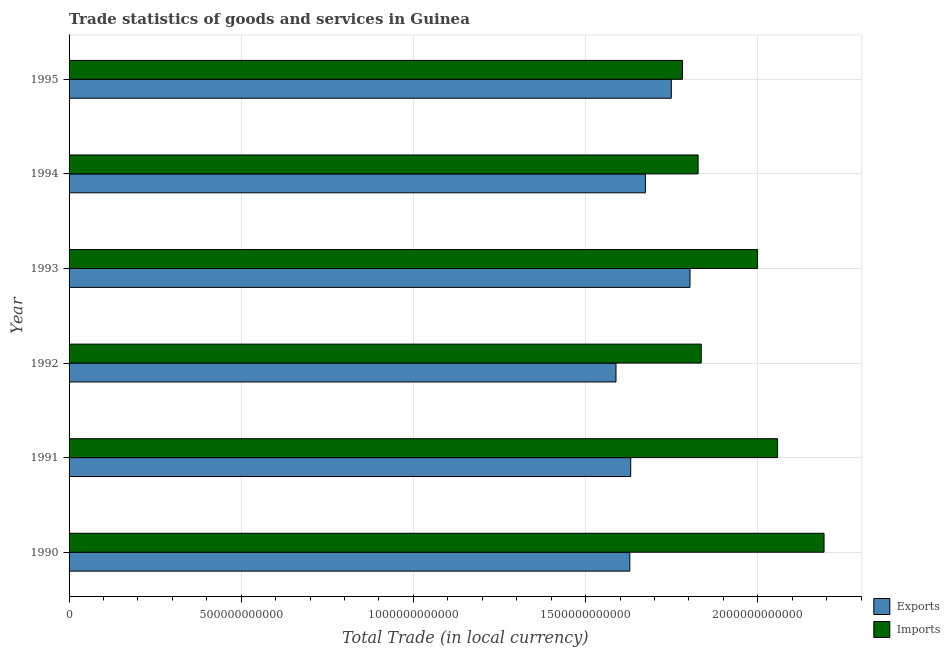How many different coloured bars are there?
Your response must be concise. 2. How many groups of bars are there?
Your answer should be very brief. 6. Are the number of bars on each tick of the Y-axis equal?
Provide a succinct answer. Yes. In how many cases, is the number of bars for a given year not equal to the number of legend labels?
Offer a very short reply. 0. What is the imports of goods and services in 1995?
Make the answer very short. 1.78e+12. Across all years, what is the maximum imports of goods and services?
Ensure brevity in your answer.  2.19e+12. Across all years, what is the minimum export of goods and services?
Keep it short and to the point. 1.59e+12. In which year was the imports of goods and services maximum?
Your answer should be very brief. 1990. In which year was the export of goods and services minimum?
Ensure brevity in your answer.  1992. What is the total export of goods and services in the graph?
Offer a very short reply. 1.01e+13. What is the difference between the imports of goods and services in 1990 and that in 1995?
Your answer should be compact. 4.11e+11. What is the difference between the imports of goods and services in 1991 and the export of goods and services in 1994?
Your answer should be compact. 3.84e+11. What is the average imports of goods and services per year?
Your answer should be compact. 1.95e+12. In the year 1992, what is the difference between the imports of goods and services and export of goods and services?
Your answer should be compact. 2.48e+11. What is the difference between the highest and the second highest imports of goods and services?
Your answer should be compact. 1.35e+11. What is the difference between the highest and the lowest imports of goods and services?
Your response must be concise. 4.11e+11. Is the sum of the export of goods and services in 1990 and 1995 greater than the maximum imports of goods and services across all years?
Your response must be concise. Yes. What does the 2nd bar from the top in 1993 represents?
Offer a very short reply. Exports. What does the 2nd bar from the bottom in 1991 represents?
Your response must be concise. Imports. What is the difference between two consecutive major ticks on the X-axis?
Provide a short and direct response. 5.00e+11. Are the values on the major ticks of X-axis written in scientific E-notation?
Your response must be concise. No. How are the legend labels stacked?
Offer a very short reply. Vertical. What is the title of the graph?
Your answer should be compact. Trade statistics of goods and services in Guinea. Does "Nitrous oxide emissions" appear as one of the legend labels in the graph?
Your response must be concise. No. What is the label or title of the X-axis?
Your response must be concise. Total Trade (in local currency). What is the Total Trade (in local currency) in Exports in 1990?
Ensure brevity in your answer.  1.63e+12. What is the Total Trade (in local currency) of Imports in 1990?
Your response must be concise. 2.19e+12. What is the Total Trade (in local currency) in Exports in 1991?
Ensure brevity in your answer.  1.63e+12. What is the Total Trade (in local currency) of Imports in 1991?
Make the answer very short. 2.06e+12. What is the Total Trade (in local currency) of Exports in 1992?
Offer a terse response. 1.59e+12. What is the Total Trade (in local currency) of Imports in 1992?
Make the answer very short. 1.84e+12. What is the Total Trade (in local currency) in Exports in 1993?
Your answer should be compact. 1.80e+12. What is the Total Trade (in local currency) of Imports in 1993?
Make the answer very short. 2.00e+12. What is the Total Trade (in local currency) in Exports in 1994?
Keep it short and to the point. 1.67e+12. What is the Total Trade (in local currency) in Imports in 1994?
Give a very brief answer. 1.83e+12. What is the Total Trade (in local currency) of Exports in 1995?
Offer a terse response. 1.75e+12. What is the Total Trade (in local currency) in Imports in 1995?
Offer a terse response. 1.78e+12. Across all years, what is the maximum Total Trade (in local currency) in Exports?
Provide a short and direct response. 1.80e+12. Across all years, what is the maximum Total Trade (in local currency) in Imports?
Offer a terse response. 2.19e+12. Across all years, what is the minimum Total Trade (in local currency) in Exports?
Make the answer very short. 1.59e+12. Across all years, what is the minimum Total Trade (in local currency) in Imports?
Your answer should be compact. 1.78e+12. What is the total Total Trade (in local currency) in Exports in the graph?
Your answer should be compact. 1.01e+13. What is the total Total Trade (in local currency) in Imports in the graph?
Offer a terse response. 1.17e+13. What is the difference between the Total Trade (in local currency) of Exports in 1990 and that in 1991?
Provide a short and direct response. -2.53e+09. What is the difference between the Total Trade (in local currency) in Imports in 1990 and that in 1991?
Your answer should be compact. 1.35e+11. What is the difference between the Total Trade (in local currency) in Exports in 1990 and that in 1992?
Give a very brief answer. 4.02e+1. What is the difference between the Total Trade (in local currency) of Imports in 1990 and that in 1992?
Ensure brevity in your answer.  3.57e+11. What is the difference between the Total Trade (in local currency) of Exports in 1990 and that in 1993?
Provide a succinct answer. -1.75e+11. What is the difference between the Total Trade (in local currency) in Imports in 1990 and that in 1993?
Provide a succinct answer. 1.93e+11. What is the difference between the Total Trade (in local currency) of Exports in 1990 and that in 1994?
Provide a short and direct response. -4.53e+1. What is the difference between the Total Trade (in local currency) in Imports in 1990 and that in 1994?
Provide a short and direct response. 3.66e+11. What is the difference between the Total Trade (in local currency) in Exports in 1990 and that in 1995?
Your response must be concise. -1.20e+11. What is the difference between the Total Trade (in local currency) of Imports in 1990 and that in 1995?
Offer a terse response. 4.11e+11. What is the difference between the Total Trade (in local currency) in Exports in 1991 and that in 1992?
Make the answer very short. 4.27e+1. What is the difference between the Total Trade (in local currency) of Imports in 1991 and that in 1992?
Your answer should be very brief. 2.22e+11. What is the difference between the Total Trade (in local currency) of Exports in 1991 and that in 1993?
Your answer should be compact. -1.72e+11. What is the difference between the Total Trade (in local currency) in Imports in 1991 and that in 1993?
Keep it short and to the point. 5.82e+1. What is the difference between the Total Trade (in local currency) in Exports in 1991 and that in 1994?
Your response must be concise. -4.27e+1. What is the difference between the Total Trade (in local currency) of Imports in 1991 and that in 1994?
Provide a short and direct response. 2.31e+11. What is the difference between the Total Trade (in local currency) of Exports in 1991 and that in 1995?
Make the answer very short. -1.18e+11. What is the difference between the Total Trade (in local currency) in Imports in 1991 and that in 1995?
Ensure brevity in your answer.  2.76e+11. What is the difference between the Total Trade (in local currency) of Exports in 1992 and that in 1993?
Provide a short and direct response. -2.15e+11. What is the difference between the Total Trade (in local currency) of Imports in 1992 and that in 1993?
Offer a very short reply. -1.64e+11. What is the difference between the Total Trade (in local currency) in Exports in 1992 and that in 1994?
Your response must be concise. -8.54e+1. What is the difference between the Total Trade (in local currency) in Imports in 1992 and that in 1994?
Provide a succinct answer. 9.11e+09. What is the difference between the Total Trade (in local currency) in Exports in 1992 and that in 1995?
Your answer should be compact. -1.61e+11. What is the difference between the Total Trade (in local currency) in Imports in 1992 and that in 1995?
Your answer should be very brief. 5.44e+1. What is the difference between the Total Trade (in local currency) in Exports in 1993 and that in 1994?
Keep it short and to the point. 1.29e+11. What is the difference between the Total Trade (in local currency) in Imports in 1993 and that in 1994?
Offer a terse response. 1.73e+11. What is the difference between the Total Trade (in local currency) of Exports in 1993 and that in 1995?
Give a very brief answer. 5.43e+1. What is the difference between the Total Trade (in local currency) in Imports in 1993 and that in 1995?
Make the answer very short. 2.18e+11. What is the difference between the Total Trade (in local currency) of Exports in 1994 and that in 1995?
Provide a short and direct response. -7.52e+1. What is the difference between the Total Trade (in local currency) of Imports in 1994 and that in 1995?
Keep it short and to the point. 4.53e+1. What is the difference between the Total Trade (in local currency) of Exports in 1990 and the Total Trade (in local currency) of Imports in 1991?
Keep it short and to the point. -4.29e+11. What is the difference between the Total Trade (in local currency) in Exports in 1990 and the Total Trade (in local currency) in Imports in 1992?
Your answer should be compact. -2.07e+11. What is the difference between the Total Trade (in local currency) in Exports in 1990 and the Total Trade (in local currency) in Imports in 1993?
Make the answer very short. -3.71e+11. What is the difference between the Total Trade (in local currency) in Exports in 1990 and the Total Trade (in local currency) in Imports in 1994?
Ensure brevity in your answer.  -1.98e+11. What is the difference between the Total Trade (in local currency) in Exports in 1990 and the Total Trade (in local currency) in Imports in 1995?
Make the answer very short. -1.53e+11. What is the difference between the Total Trade (in local currency) in Exports in 1991 and the Total Trade (in local currency) in Imports in 1992?
Offer a very short reply. -2.05e+11. What is the difference between the Total Trade (in local currency) of Exports in 1991 and the Total Trade (in local currency) of Imports in 1993?
Your answer should be compact. -3.68e+11. What is the difference between the Total Trade (in local currency) of Exports in 1991 and the Total Trade (in local currency) of Imports in 1994?
Give a very brief answer. -1.96e+11. What is the difference between the Total Trade (in local currency) of Exports in 1991 and the Total Trade (in local currency) of Imports in 1995?
Keep it short and to the point. -1.50e+11. What is the difference between the Total Trade (in local currency) in Exports in 1992 and the Total Trade (in local currency) in Imports in 1993?
Offer a terse response. -4.11e+11. What is the difference between the Total Trade (in local currency) of Exports in 1992 and the Total Trade (in local currency) of Imports in 1994?
Your answer should be compact. -2.38e+11. What is the difference between the Total Trade (in local currency) in Exports in 1992 and the Total Trade (in local currency) in Imports in 1995?
Your answer should be very brief. -1.93e+11. What is the difference between the Total Trade (in local currency) in Exports in 1993 and the Total Trade (in local currency) in Imports in 1994?
Your answer should be compact. -2.35e+1. What is the difference between the Total Trade (in local currency) in Exports in 1993 and the Total Trade (in local currency) in Imports in 1995?
Provide a short and direct response. 2.18e+1. What is the difference between the Total Trade (in local currency) of Exports in 1994 and the Total Trade (in local currency) of Imports in 1995?
Offer a very short reply. -1.08e+11. What is the average Total Trade (in local currency) in Exports per year?
Give a very brief answer. 1.68e+12. What is the average Total Trade (in local currency) of Imports per year?
Provide a succinct answer. 1.95e+12. In the year 1990, what is the difference between the Total Trade (in local currency) in Exports and Total Trade (in local currency) in Imports?
Give a very brief answer. -5.64e+11. In the year 1991, what is the difference between the Total Trade (in local currency) in Exports and Total Trade (in local currency) in Imports?
Provide a short and direct response. -4.27e+11. In the year 1992, what is the difference between the Total Trade (in local currency) of Exports and Total Trade (in local currency) of Imports?
Keep it short and to the point. -2.48e+11. In the year 1993, what is the difference between the Total Trade (in local currency) of Exports and Total Trade (in local currency) of Imports?
Provide a succinct answer. -1.96e+11. In the year 1994, what is the difference between the Total Trade (in local currency) in Exports and Total Trade (in local currency) in Imports?
Give a very brief answer. -1.53e+11. In the year 1995, what is the difference between the Total Trade (in local currency) in Exports and Total Trade (in local currency) in Imports?
Ensure brevity in your answer.  -3.25e+1. What is the ratio of the Total Trade (in local currency) of Exports in 1990 to that in 1991?
Give a very brief answer. 1. What is the ratio of the Total Trade (in local currency) of Imports in 1990 to that in 1991?
Give a very brief answer. 1.07. What is the ratio of the Total Trade (in local currency) of Exports in 1990 to that in 1992?
Your response must be concise. 1.03. What is the ratio of the Total Trade (in local currency) of Imports in 1990 to that in 1992?
Ensure brevity in your answer.  1.19. What is the ratio of the Total Trade (in local currency) in Exports in 1990 to that in 1993?
Provide a short and direct response. 0.9. What is the ratio of the Total Trade (in local currency) in Imports in 1990 to that in 1993?
Offer a terse response. 1.1. What is the ratio of the Total Trade (in local currency) in Exports in 1990 to that in 1994?
Your answer should be compact. 0.97. What is the ratio of the Total Trade (in local currency) of Imports in 1990 to that in 1994?
Ensure brevity in your answer.  1.2. What is the ratio of the Total Trade (in local currency) in Exports in 1990 to that in 1995?
Ensure brevity in your answer.  0.93. What is the ratio of the Total Trade (in local currency) of Imports in 1990 to that in 1995?
Offer a very short reply. 1.23. What is the ratio of the Total Trade (in local currency) in Exports in 1991 to that in 1992?
Your response must be concise. 1.03. What is the ratio of the Total Trade (in local currency) of Imports in 1991 to that in 1992?
Keep it short and to the point. 1.12. What is the ratio of the Total Trade (in local currency) in Exports in 1991 to that in 1993?
Keep it short and to the point. 0.9. What is the ratio of the Total Trade (in local currency) of Imports in 1991 to that in 1993?
Offer a very short reply. 1.03. What is the ratio of the Total Trade (in local currency) in Exports in 1991 to that in 1994?
Give a very brief answer. 0.97. What is the ratio of the Total Trade (in local currency) in Imports in 1991 to that in 1994?
Give a very brief answer. 1.13. What is the ratio of the Total Trade (in local currency) in Exports in 1991 to that in 1995?
Your answer should be compact. 0.93. What is the ratio of the Total Trade (in local currency) in Imports in 1991 to that in 1995?
Keep it short and to the point. 1.16. What is the ratio of the Total Trade (in local currency) of Exports in 1992 to that in 1993?
Offer a very short reply. 0.88. What is the ratio of the Total Trade (in local currency) in Imports in 1992 to that in 1993?
Offer a very short reply. 0.92. What is the ratio of the Total Trade (in local currency) of Exports in 1992 to that in 1994?
Your answer should be compact. 0.95. What is the ratio of the Total Trade (in local currency) of Imports in 1992 to that in 1994?
Keep it short and to the point. 1. What is the ratio of the Total Trade (in local currency) of Exports in 1992 to that in 1995?
Provide a short and direct response. 0.91. What is the ratio of the Total Trade (in local currency) in Imports in 1992 to that in 1995?
Provide a succinct answer. 1.03. What is the ratio of the Total Trade (in local currency) in Exports in 1993 to that in 1994?
Your answer should be compact. 1.08. What is the ratio of the Total Trade (in local currency) of Imports in 1993 to that in 1994?
Keep it short and to the point. 1.09. What is the ratio of the Total Trade (in local currency) of Exports in 1993 to that in 1995?
Your answer should be compact. 1.03. What is the ratio of the Total Trade (in local currency) in Imports in 1993 to that in 1995?
Provide a succinct answer. 1.12. What is the ratio of the Total Trade (in local currency) of Exports in 1994 to that in 1995?
Keep it short and to the point. 0.96. What is the ratio of the Total Trade (in local currency) of Imports in 1994 to that in 1995?
Ensure brevity in your answer.  1.03. What is the difference between the highest and the second highest Total Trade (in local currency) of Exports?
Your response must be concise. 5.43e+1. What is the difference between the highest and the second highest Total Trade (in local currency) in Imports?
Your answer should be very brief. 1.35e+11. What is the difference between the highest and the lowest Total Trade (in local currency) of Exports?
Keep it short and to the point. 2.15e+11. What is the difference between the highest and the lowest Total Trade (in local currency) in Imports?
Give a very brief answer. 4.11e+11. 